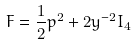<formula> <loc_0><loc_0><loc_500><loc_500>F = \frac { 1 } { 2 } p ^ { 2 } + 2 y ^ { - 2 } I _ { 4 }</formula> 